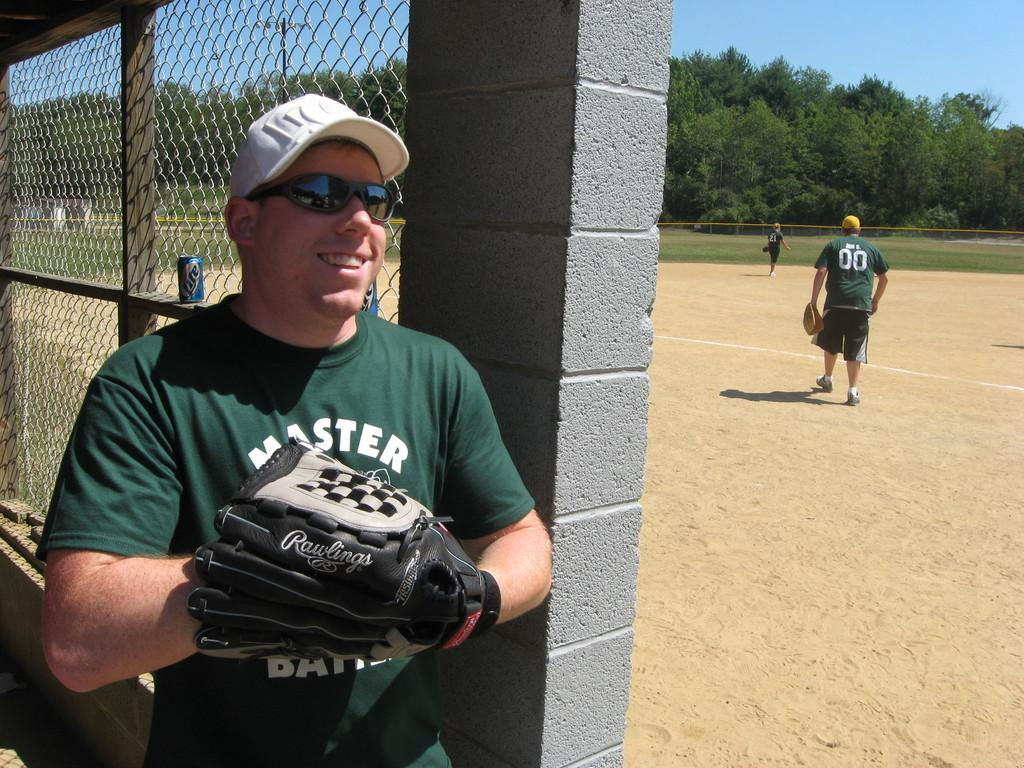<image>
Create a compact narrative representing the image presented. Man wearing a green shirt which says MASTER on it. 